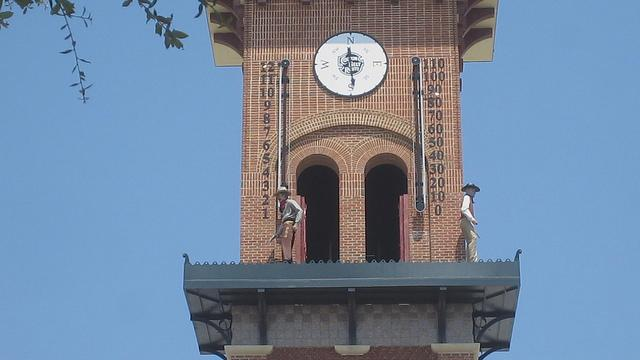What is the device shown in the image?

Choices:
A) compass
B) painting
C) clock
D) photography compass 